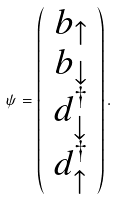Convert formula to latex. <formula><loc_0><loc_0><loc_500><loc_500>\psi = \left ( \begin{array} { c } b _ { \uparrow } \\ b _ { \downarrow } \\ d ^ { \dag } _ { \downarrow } \\ d ^ { \dag } _ { \uparrow } \end{array} \right ) .</formula> 